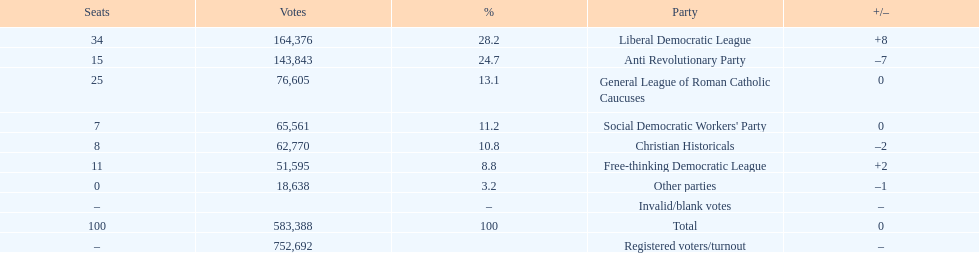Name the top three parties? Liberal Democratic League, Anti Revolutionary Party, General League of Roman Catholic Caucuses. 